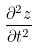<formula> <loc_0><loc_0><loc_500><loc_500>\frac { \partial ^ { 2 } z } { \partial t ^ { 2 } }</formula> 